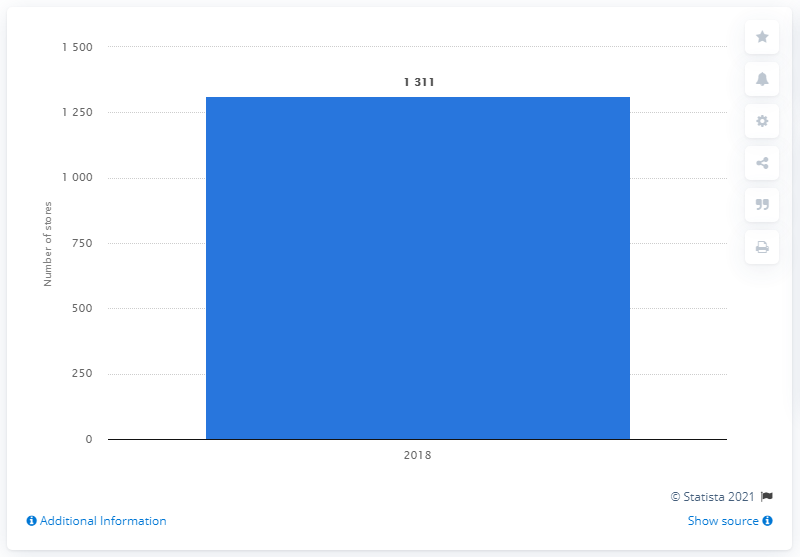Specify some key components in this picture. In the year 2018, the Cato Corporation operated a total of 1,311 stores in the United States. 